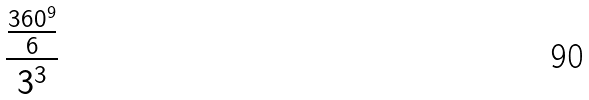<formula> <loc_0><loc_0><loc_500><loc_500>\frac { \frac { 3 6 0 ^ { 9 } } { 6 } } { 3 ^ { 3 } }</formula> 